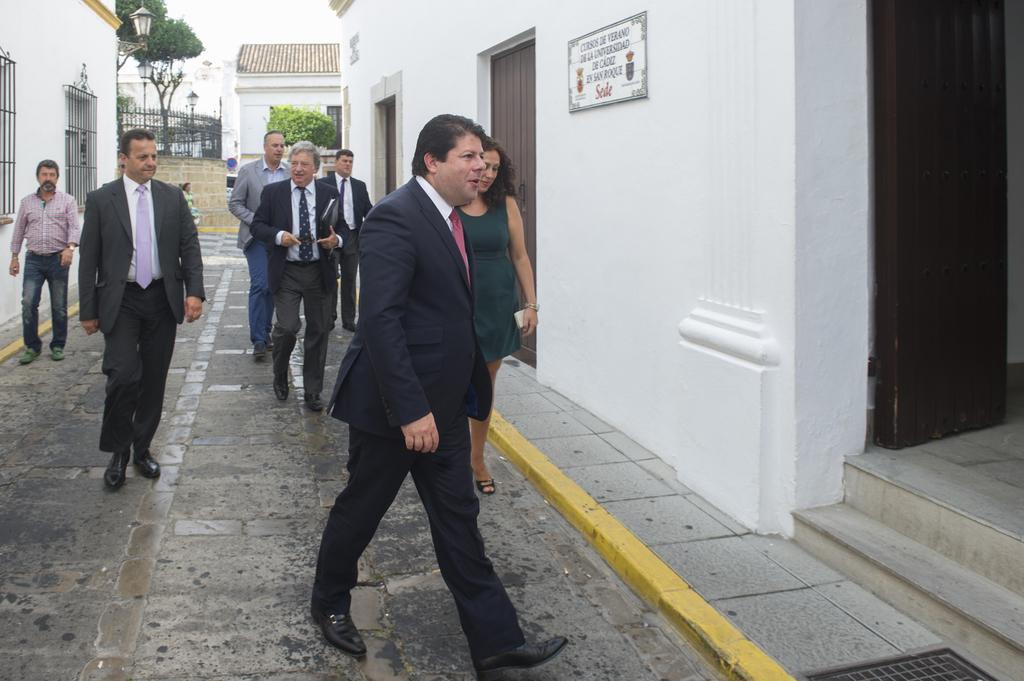How would you summarize this image in a sentence or two? In the picture group of people are walking into a room,all of them are men and there is only one woman among them,most of them are wearing blazers and behind these people there is another complex and in the background there are few trees. 